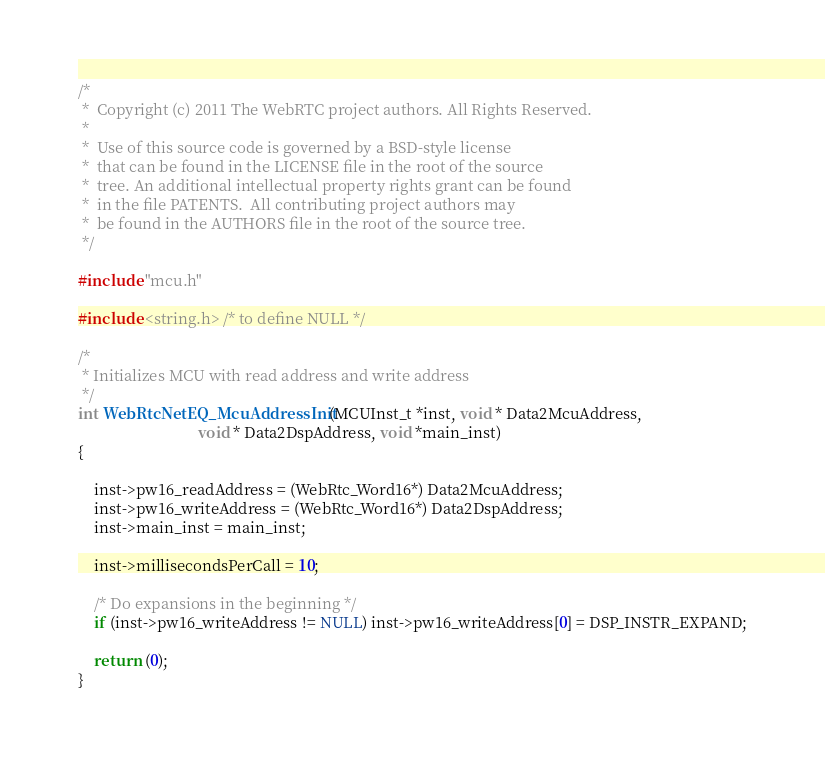<code> <loc_0><loc_0><loc_500><loc_500><_C_>/*
 *  Copyright (c) 2011 The WebRTC project authors. All Rights Reserved.
 *
 *  Use of this source code is governed by a BSD-style license
 *  that can be found in the LICENSE file in the root of the source
 *  tree. An additional intellectual property rights grant can be found
 *  in the file PATENTS.  All contributing project authors may
 *  be found in the AUTHORS file in the root of the source tree.
 */

#include "mcu.h"

#include <string.h> /* to define NULL */

/*
 * Initializes MCU with read address and write address
 */
int WebRtcNetEQ_McuAddressInit(MCUInst_t *inst, void * Data2McuAddress,
                               void * Data2DspAddress, void *main_inst)
{

    inst->pw16_readAddress = (WebRtc_Word16*) Data2McuAddress;
    inst->pw16_writeAddress = (WebRtc_Word16*) Data2DspAddress;
    inst->main_inst = main_inst;

    inst->millisecondsPerCall = 10;

    /* Do expansions in the beginning */
    if (inst->pw16_writeAddress != NULL) inst->pw16_writeAddress[0] = DSP_INSTR_EXPAND;

    return (0);
}

</code> 